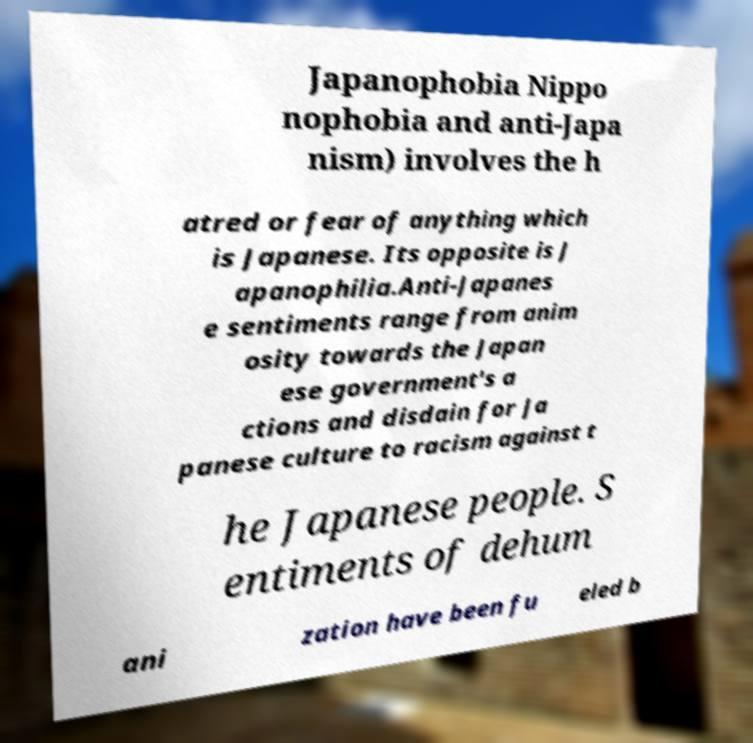Can you read and provide the text displayed in the image?This photo seems to have some interesting text. Can you extract and type it out for me? Japanophobia Nippo nophobia and anti-Japa nism) involves the h atred or fear of anything which is Japanese. Its opposite is J apanophilia.Anti-Japanes e sentiments range from anim osity towards the Japan ese government's a ctions and disdain for Ja panese culture to racism against t he Japanese people. S entiments of dehum ani zation have been fu eled b 